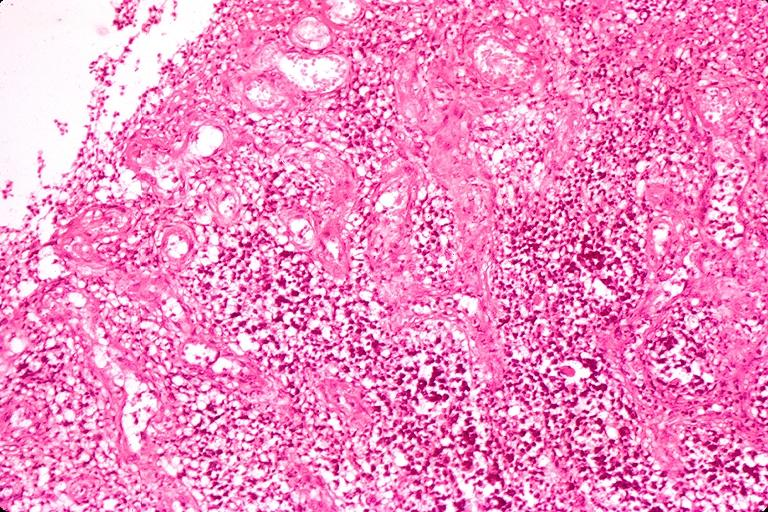what is present?
Answer the question using a single word or phrase. Oral 